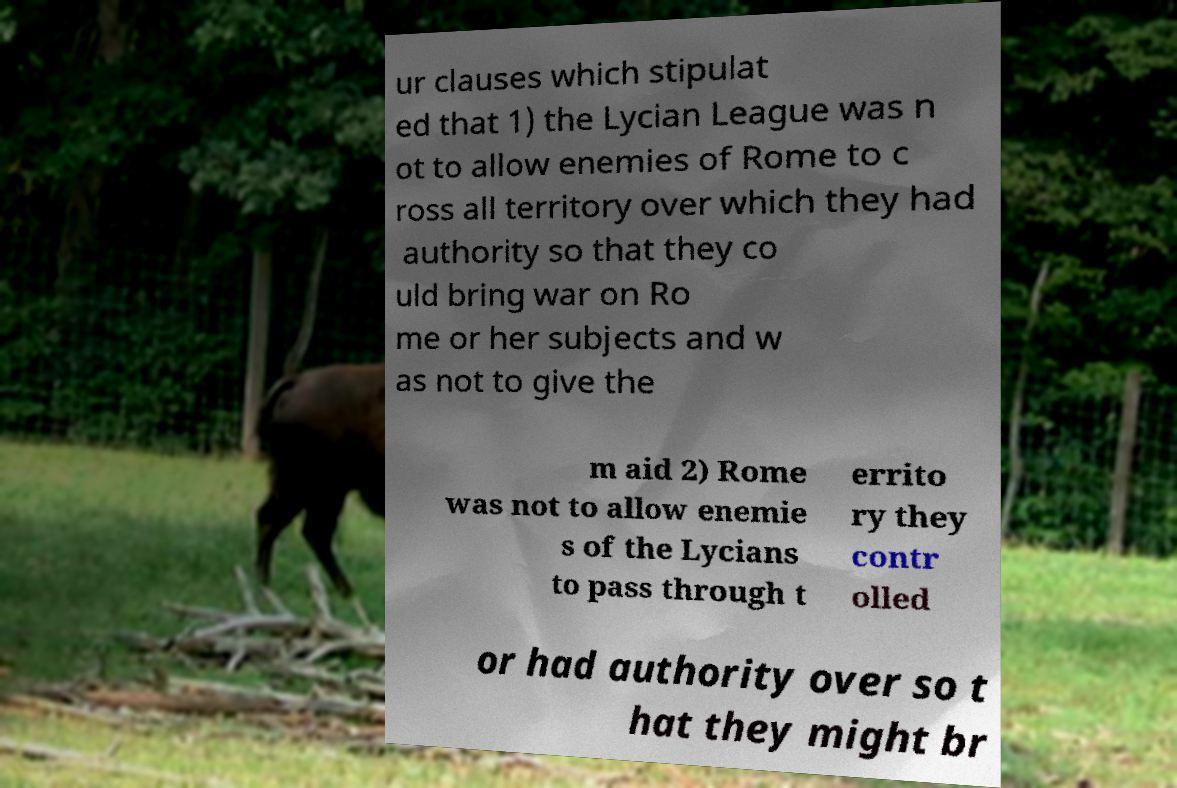I need the written content from this picture converted into text. Can you do that? ur clauses which stipulat ed that 1) the Lycian League was n ot to allow enemies of Rome to c ross all territory over which they had authority so that they co uld bring war on Ro me or her subjects and w as not to give the m aid 2) Rome was not to allow enemie s of the Lycians to pass through t errito ry they contr olled or had authority over so t hat they might br 